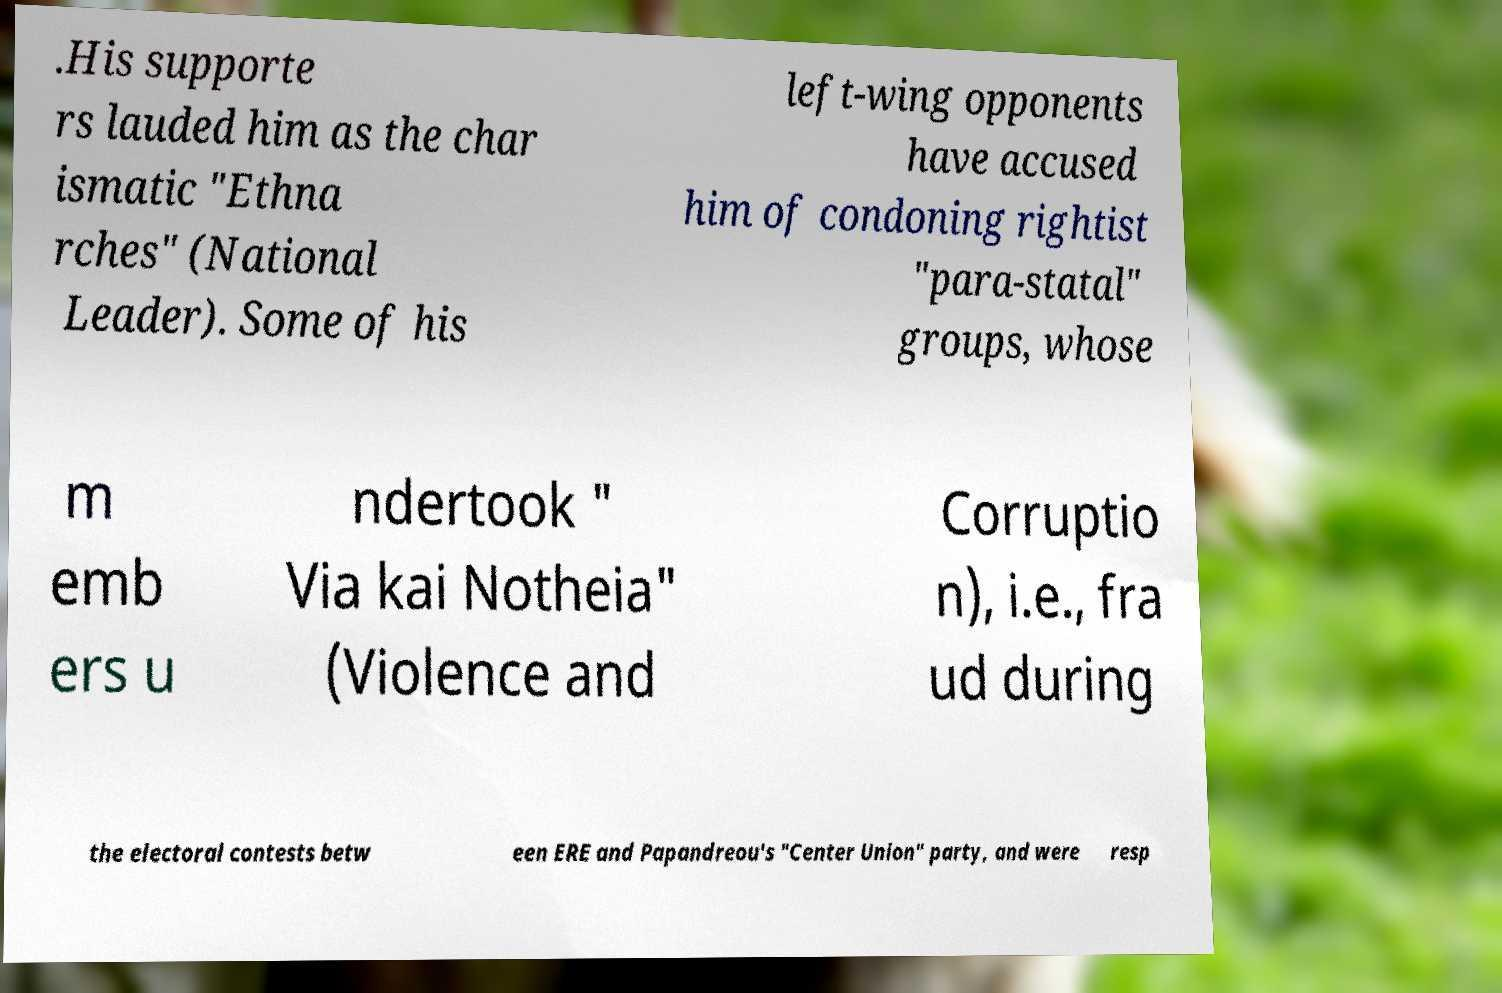Could you extract and type out the text from this image? .His supporte rs lauded him as the char ismatic "Ethna rches" (National Leader). Some of his left-wing opponents have accused him of condoning rightist "para-statal" groups, whose m emb ers u ndertook " Via kai Notheia" (Violence and Corruptio n), i.e., fra ud during the electoral contests betw een ERE and Papandreou's "Center Union" party, and were resp 